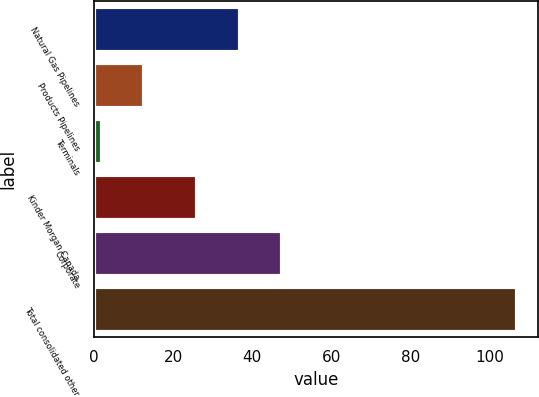Convert chart to OTSL. <chart><loc_0><loc_0><loc_500><loc_500><bar_chart><fcel>Natural Gas Pipelines<fcel>Products Pipelines<fcel>Terminals<fcel>Kinder Morgan Canada<fcel>Corporate<fcel>Total consolidated other<nl><fcel>37<fcel>12.5<fcel>2<fcel>26<fcel>47.5<fcel>107<nl></chart> 